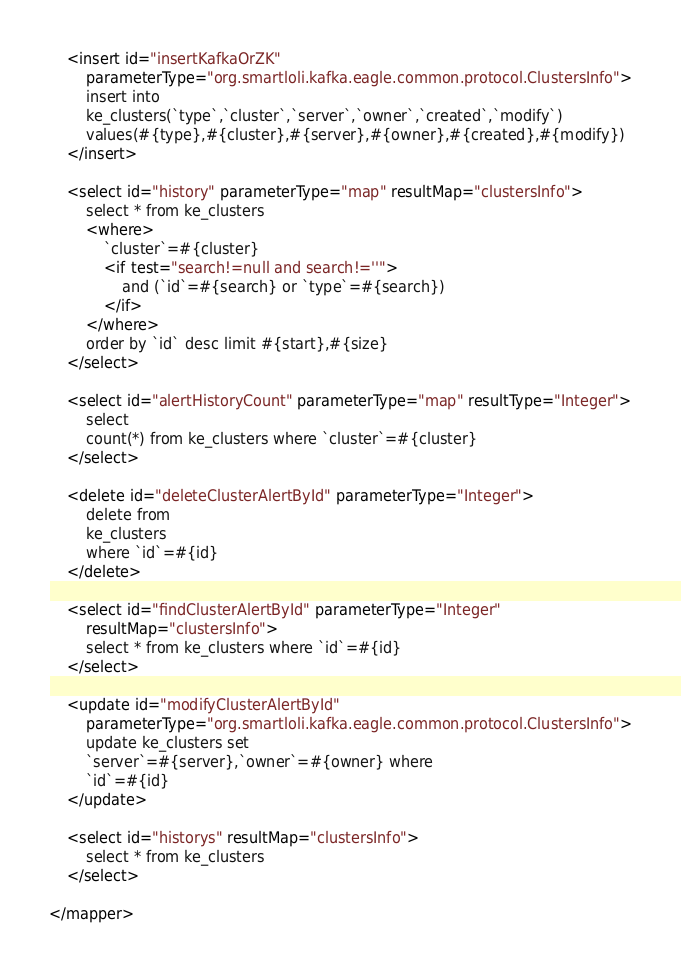<code> <loc_0><loc_0><loc_500><loc_500><_XML_>	<insert id="insertKafkaOrZK"
		parameterType="org.smartloli.kafka.eagle.common.protocol.ClustersInfo">
		insert into
		ke_clusters(`type`,`cluster`,`server`,`owner`,`created`,`modify`)
		values(#{type},#{cluster},#{server},#{owner},#{created},#{modify})
	</insert>

	<select id="history" parameterType="map" resultMap="clustersInfo">
		select * from ke_clusters
		<where>
			`cluster`=#{cluster}
			<if test="search!=null and search!=''">
				and (`id`=#{search} or `type`=#{search})
			</if>
		</where>
		order by `id` desc limit #{start},#{size}
	</select>

	<select id="alertHistoryCount" parameterType="map" resultType="Integer">
		select
		count(*) from ke_clusters where `cluster`=#{cluster}
	</select>

	<delete id="deleteClusterAlertById" parameterType="Integer">
		delete from
		ke_clusters
		where `id`=#{id}
	</delete>

	<select id="findClusterAlertById" parameterType="Integer"
		resultMap="clustersInfo">
		select * from ke_clusters where `id`=#{id}
	</select>

	<update id="modifyClusterAlertById"
		parameterType="org.smartloli.kafka.eagle.common.protocol.ClustersInfo">
		update ke_clusters set
		`server`=#{server},`owner`=#{owner} where
		`id`=#{id}
	</update>

	<select id="historys" resultMap="clustersInfo">
		select * from ke_clusters
	</select>

</mapper></code> 